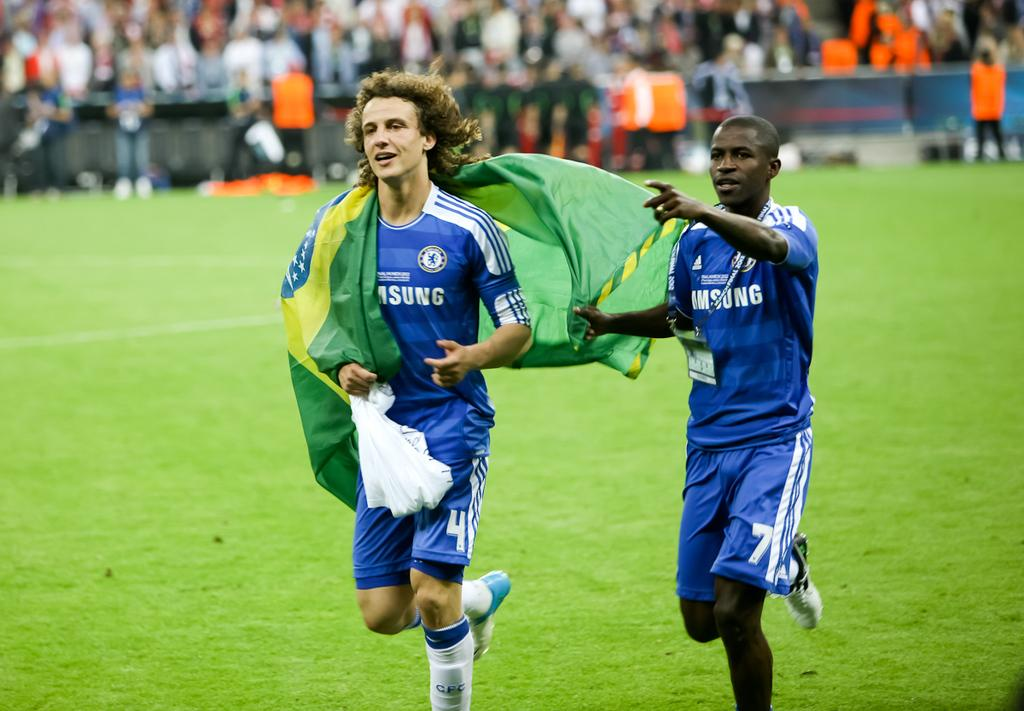Provide a one-sentence caption for the provided image. Two soccer players wearing blue jerseys only half the word is showing saying sung. 